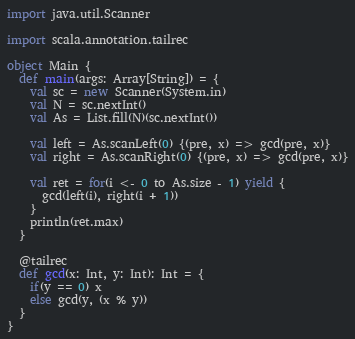Convert code to text. <code><loc_0><loc_0><loc_500><loc_500><_Scala_>import java.util.Scanner

import scala.annotation.tailrec

object Main {
  def main(args: Array[String]) = {
    val sc = new Scanner(System.in)
    val N = sc.nextInt()
    val As = List.fill(N)(sc.nextInt())

    val left = As.scanLeft(0) {(pre, x) => gcd(pre, x)}
    val right = As.scanRight(0) {(pre, x) => gcd(pre, x)}

    val ret = for(i <- 0 to As.size - 1) yield {
      gcd(left(i), right(i + 1))
    }
    println(ret.max)
  }

  @tailrec
  def gcd(x: Int, y: Int): Int = {
    if(y == 0) x
    else gcd(y, (x % y))
  }
}</code> 